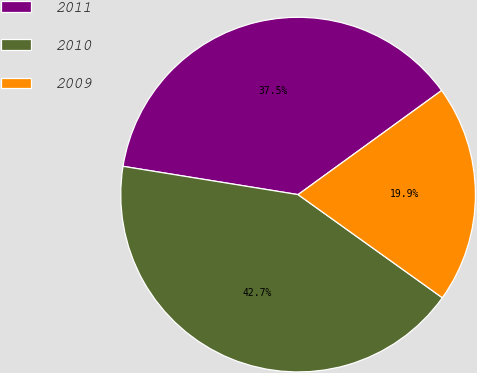<chart> <loc_0><loc_0><loc_500><loc_500><pie_chart><fcel>2011<fcel>2010<fcel>2009<nl><fcel>37.46%<fcel>42.67%<fcel>19.87%<nl></chart> 